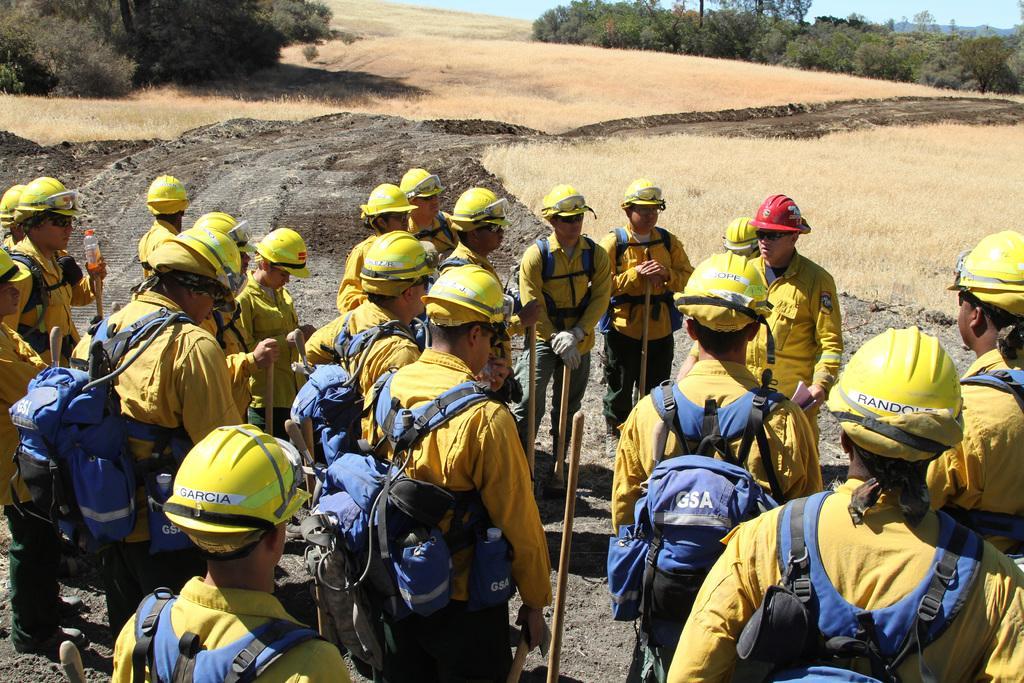How would you summarize this image in a sentence or two? In this image, we can see persons wearing bags and helmets. There is a grass on the ground. There are plants in the top left and in the top right of the image. 